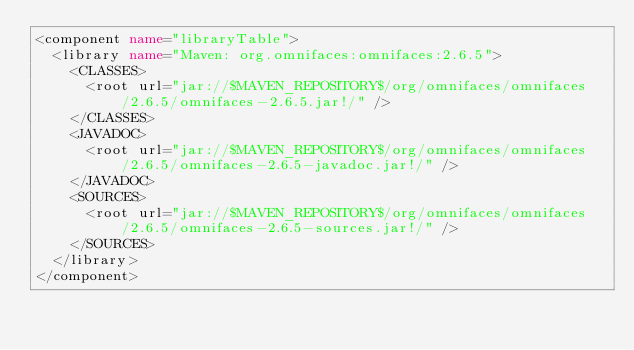Convert code to text. <code><loc_0><loc_0><loc_500><loc_500><_XML_><component name="libraryTable">
  <library name="Maven: org.omnifaces:omnifaces:2.6.5">
    <CLASSES>
      <root url="jar://$MAVEN_REPOSITORY$/org/omnifaces/omnifaces/2.6.5/omnifaces-2.6.5.jar!/" />
    </CLASSES>
    <JAVADOC>
      <root url="jar://$MAVEN_REPOSITORY$/org/omnifaces/omnifaces/2.6.5/omnifaces-2.6.5-javadoc.jar!/" />
    </JAVADOC>
    <SOURCES>
      <root url="jar://$MAVEN_REPOSITORY$/org/omnifaces/omnifaces/2.6.5/omnifaces-2.6.5-sources.jar!/" />
    </SOURCES>
  </library>
</component></code> 